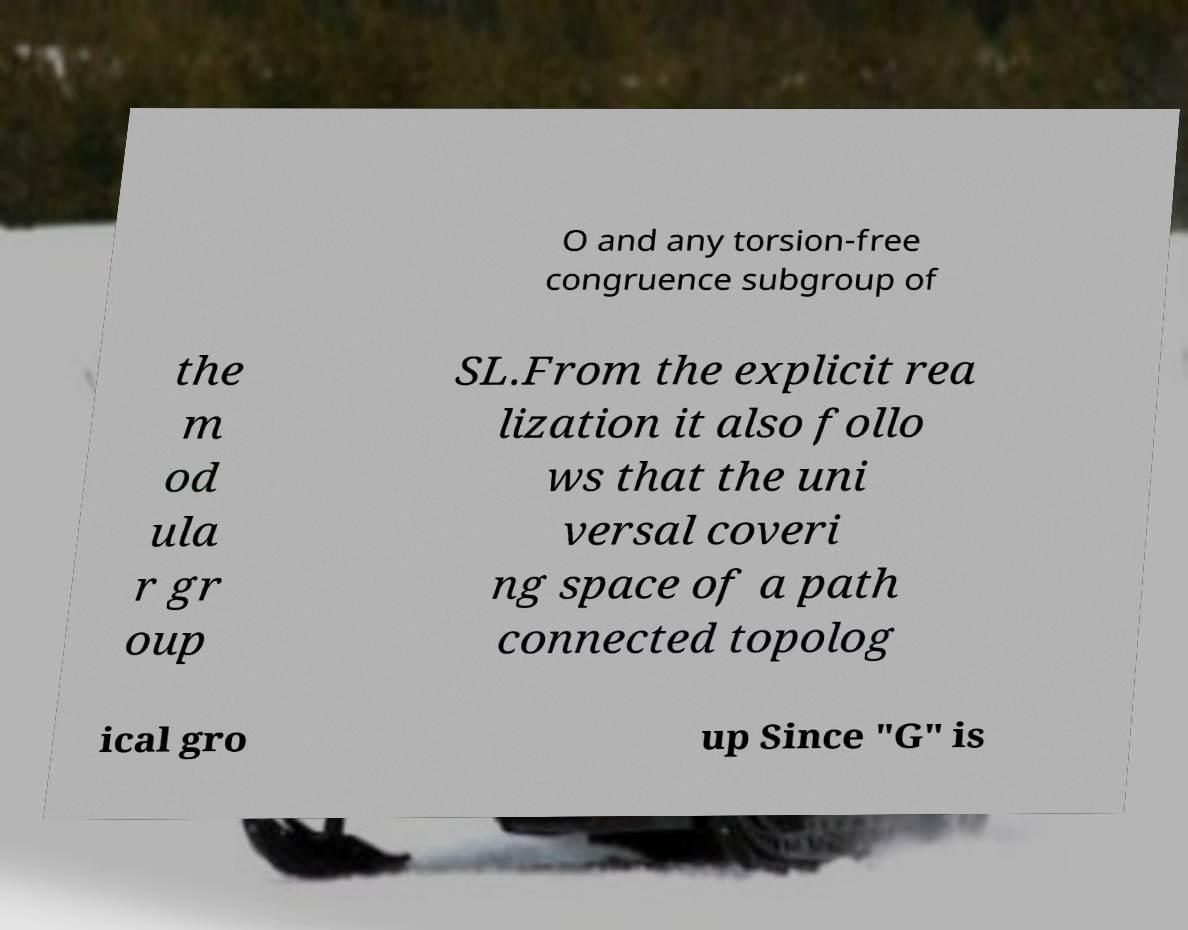There's text embedded in this image that I need extracted. Can you transcribe it verbatim? O and any torsion-free congruence subgroup of the m od ula r gr oup SL.From the explicit rea lization it also follo ws that the uni versal coveri ng space of a path connected topolog ical gro up Since "G" is 